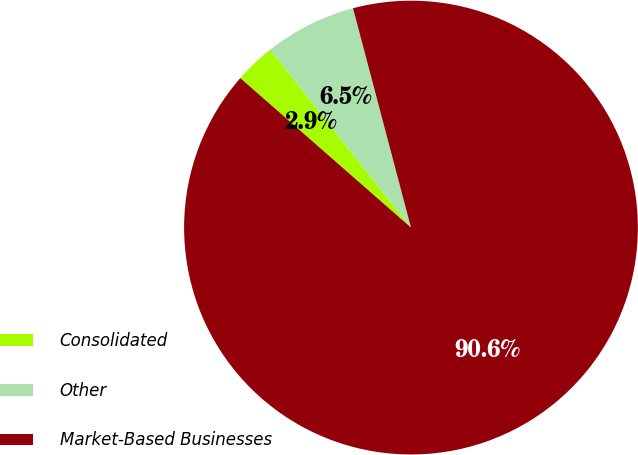Convert chart to OTSL. <chart><loc_0><loc_0><loc_500><loc_500><pie_chart><fcel>Consolidated<fcel>Other<fcel>Market-Based Businesses<nl><fcel>2.9%<fcel>6.54%<fcel>90.56%<nl></chart> 